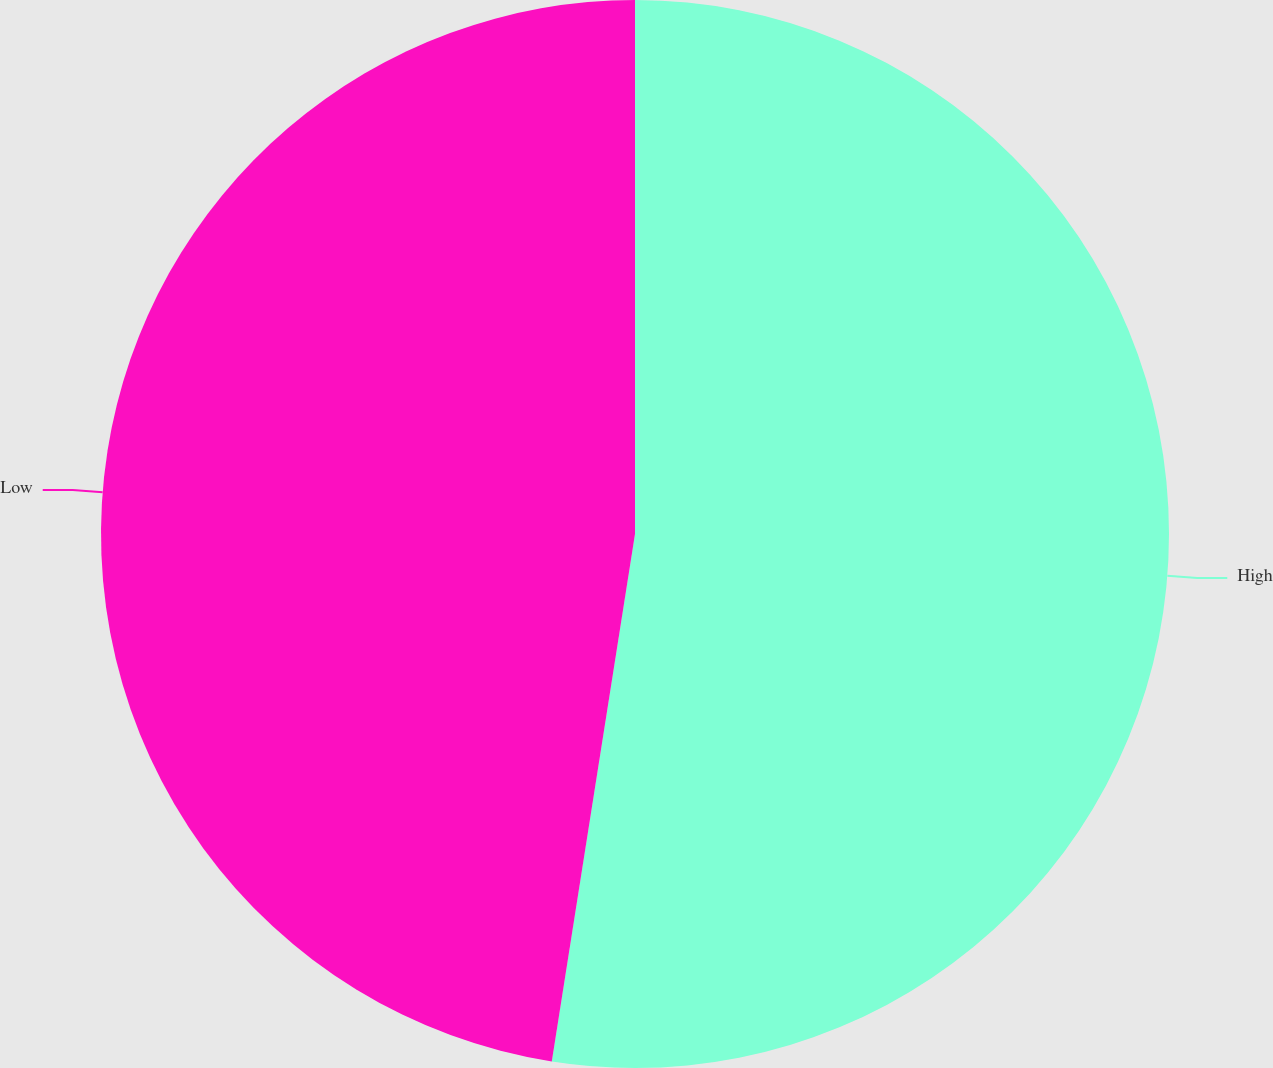Convert chart to OTSL. <chart><loc_0><loc_0><loc_500><loc_500><pie_chart><fcel>High<fcel>Low<nl><fcel>52.49%<fcel>47.51%<nl></chart> 